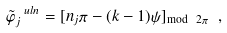Convert formula to latex. <formula><loc_0><loc_0><loc_500><loc_500>\tilde { \varphi } _ { j } ^ { \ u l { n } } = [ n _ { j } \pi - ( k - 1 ) \psi ] _ { \text {mod} \ 2 \pi } \ ,</formula> 